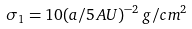<formula> <loc_0><loc_0><loc_500><loc_500>\sigma _ { 1 } = 1 0 ( a / 5 \, A U ) ^ { - 2 } \, g / c m ^ { 2 }</formula> 